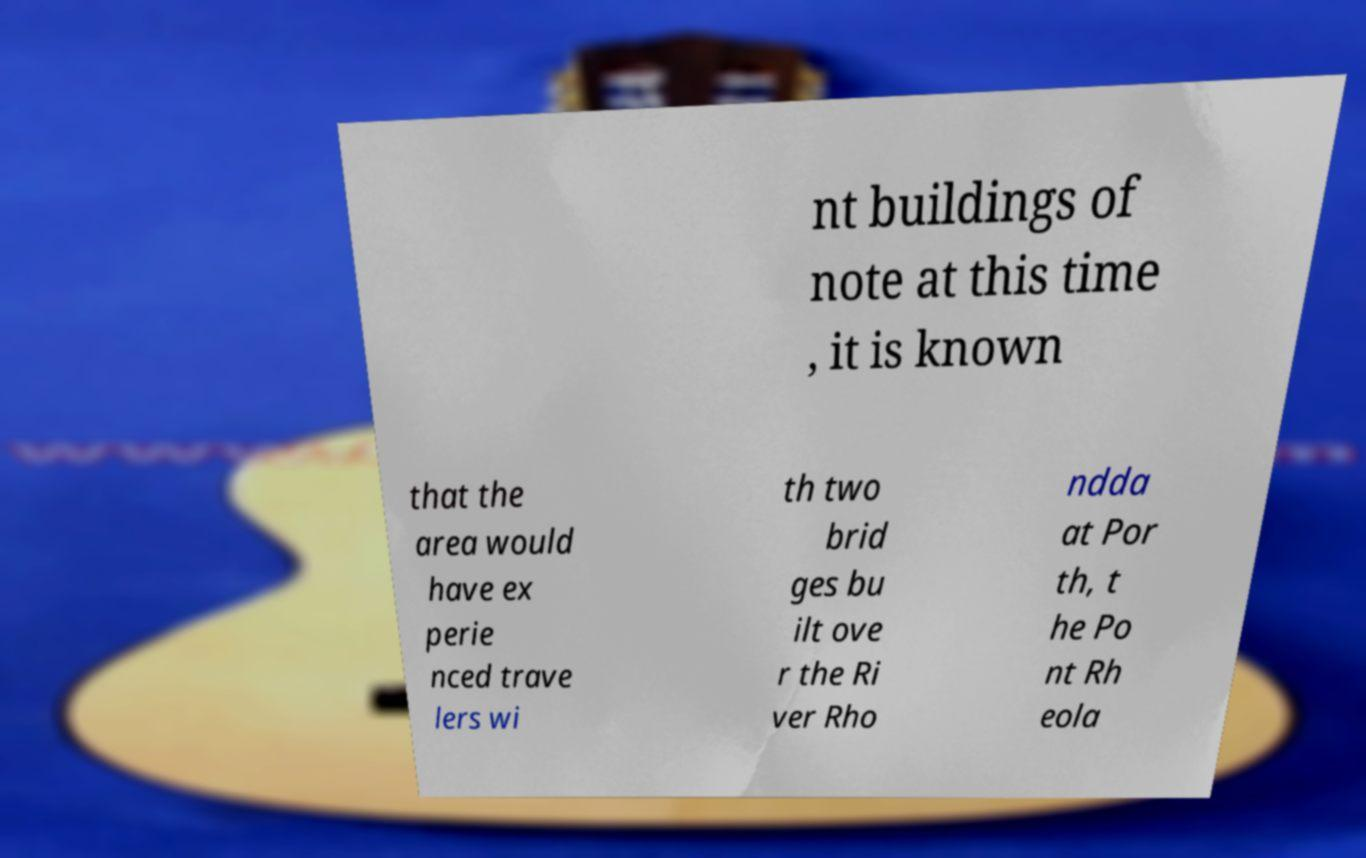There's text embedded in this image that I need extracted. Can you transcribe it verbatim? nt buildings of note at this time , it is known that the area would have ex perie nced trave lers wi th two brid ges bu ilt ove r the Ri ver Rho ndda at Por th, t he Po nt Rh eola 